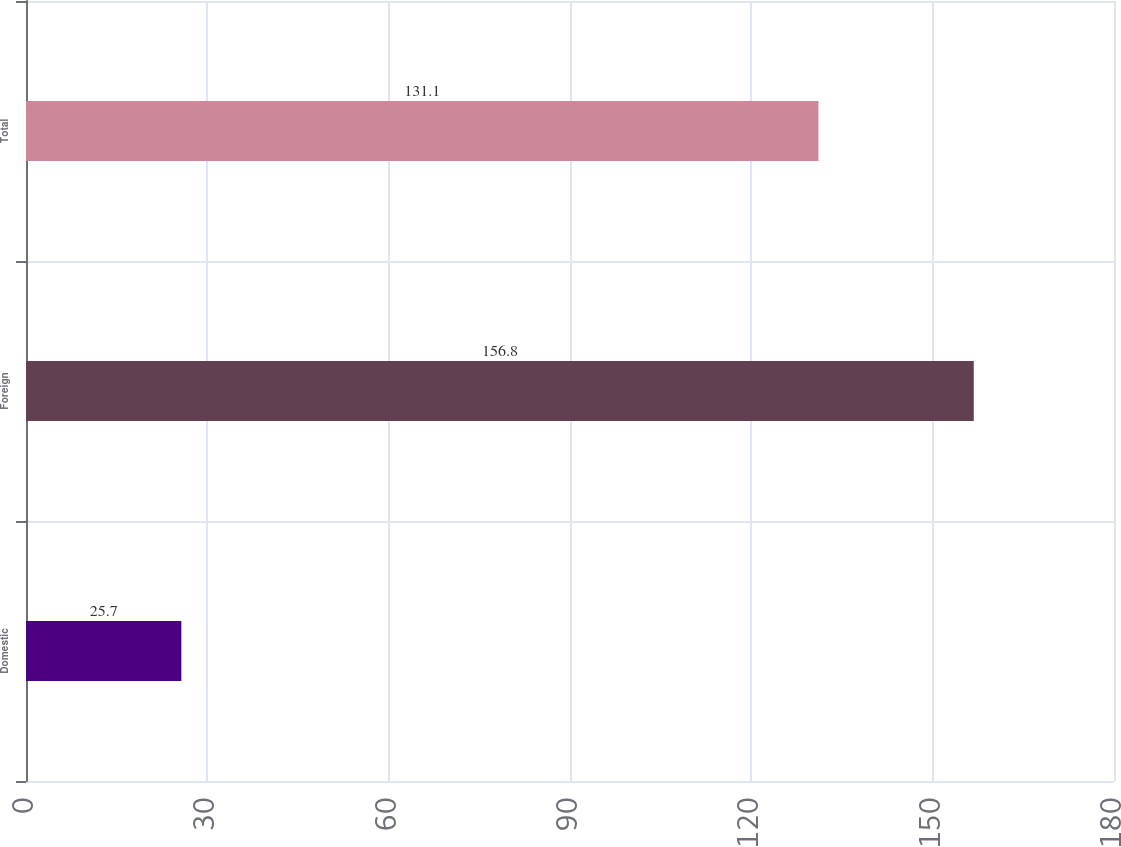<chart> <loc_0><loc_0><loc_500><loc_500><bar_chart><fcel>Domestic<fcel>Foreign<fcel>Total<nl><fcel>25.7<fcel>156.8<fcel>131.1<nl></chart> 